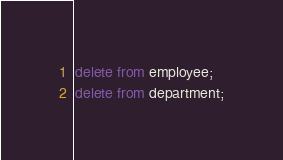Convert code to text. <code><loc_0><loc_0><loc_500><loc_500><_SQL_>delete from employee;
delete from department;</code> 